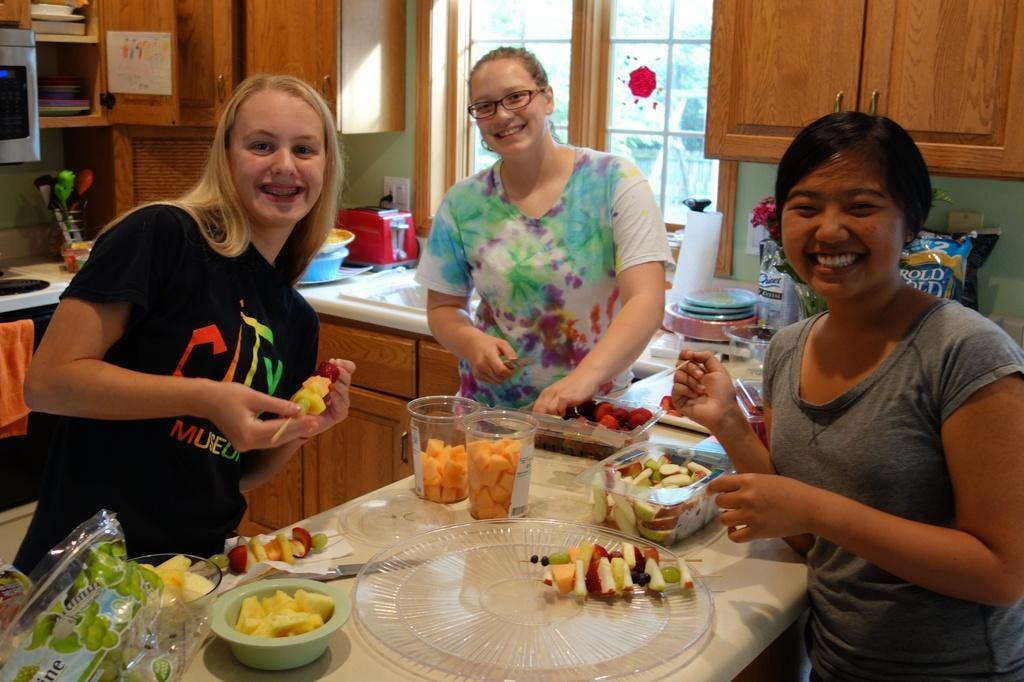Could you give a brief overview of what you see in this image? This image contains three women standing before a table. On table there is a cup, jar, bowl and a plate having some fruit in it. Woman at the left side is wearing a black shirt and holding fruits in her hand. Person at the middle is wearing a white shirt. There are plates on the kitchen cabinet. There is a toaster and at the backside of this person there is a window. 